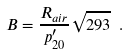<formula> <loc_0><loc_0><loc_500><loc_500>\ B = \frac { R _ { a i r } } { p ^ { \prime } _ { 2 0 } } \sqrt { 2 9 3 } \ .</formula> 